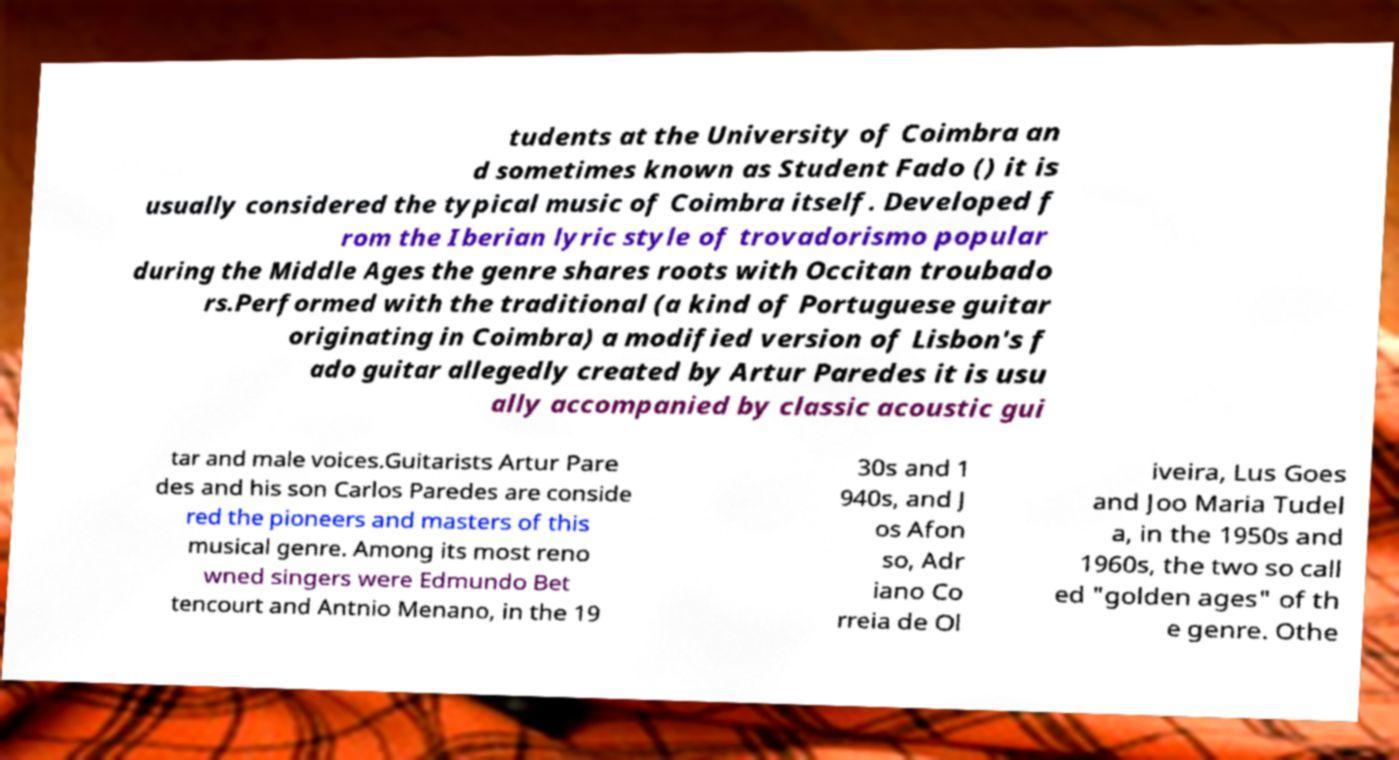There's text embedded in this image that I need extracted. Can you transcribe it verbatim? tudents at the University of Coimbra an d sometimes known as Student Fado () it is usually considered the typical music of Coimbra itself. Developed f rom the Iberian lyric style of trovadorismo popular during the Middle Ages the genre shares roots with Occitan troubado rs.Performed with the traditional (a kind of Portuguese guitar originating in Coimbra) a modified version of Lisbon's f ado guitar allegedly created by Artur Paredes it is usu ally accompanied by classic acoustic gui tar and male voices.Guitarists Artur Pare des and his son Carlos Paredes are conside red the pioneers and masters of this musical genre. Among its most reno wned singers were Edmundo Bet tencourt and Antnio Menano, in the 19 30s and 1 940s, and J os Afon so, Adr iano Co rreia de Ol iveira, Lus Goes and Joo Maria Tudel a, in the 1950s and 1960s, the two so call ed "golden ages" of th e genre. Othe 